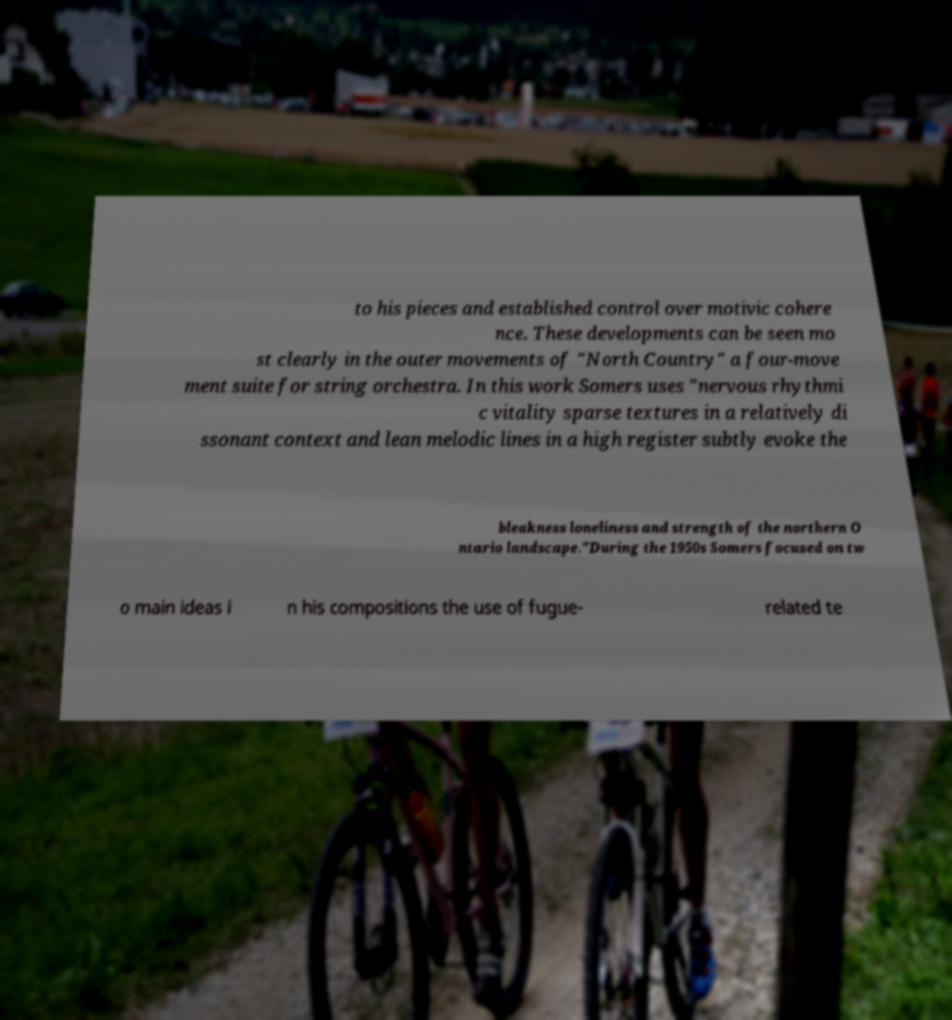Could you assist in decoding the text presented in this image and type it out clearly? to his pieces and established control over motivic cohere nce. These developments can be seen mo st clearly in the outer movements of "North Country" a four-move ment suite for string orchestra. In this work Somers uses "nervous rhythmi c vitality sparse textures in a relatively di ssonant context and lean melodic lines in a high register subtly evoke the bleakness loneliness and strength of the northern O ntario landscape."During the 1950s Somers focused on tw o main ideas i n his compositions the use of fugue- related te 